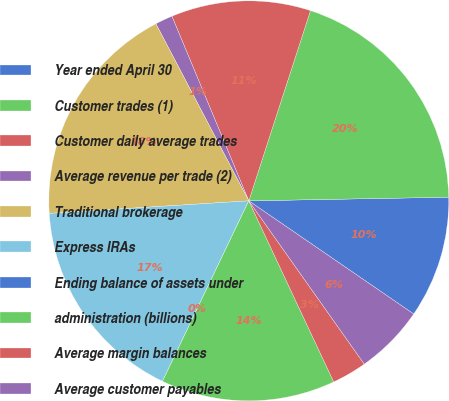<chart> <loc_0><loc_0><loc_500><loc_500><pie_chart><fcel>Year ended April 30<fcel>Customer trades (1)<fcel>Customer daily average trades<fcel>Average revenue per trade (2)<fcel>Traditional brokerage<fcel>Express IRAs<fcel>Ending balance of assets under<fcel>administration (billions)<fcel>Average margin balances<fcel>Average customer payables<nl><fcel>9.86%<fcel>19.72%<fcel>11.27%<fcel>1.41%<fcel>18.31%<fcel>16.9%<fcel>0.0%<fcel>14.08%<fcel>2.82%<fcel>5.63%<nl></chart> 